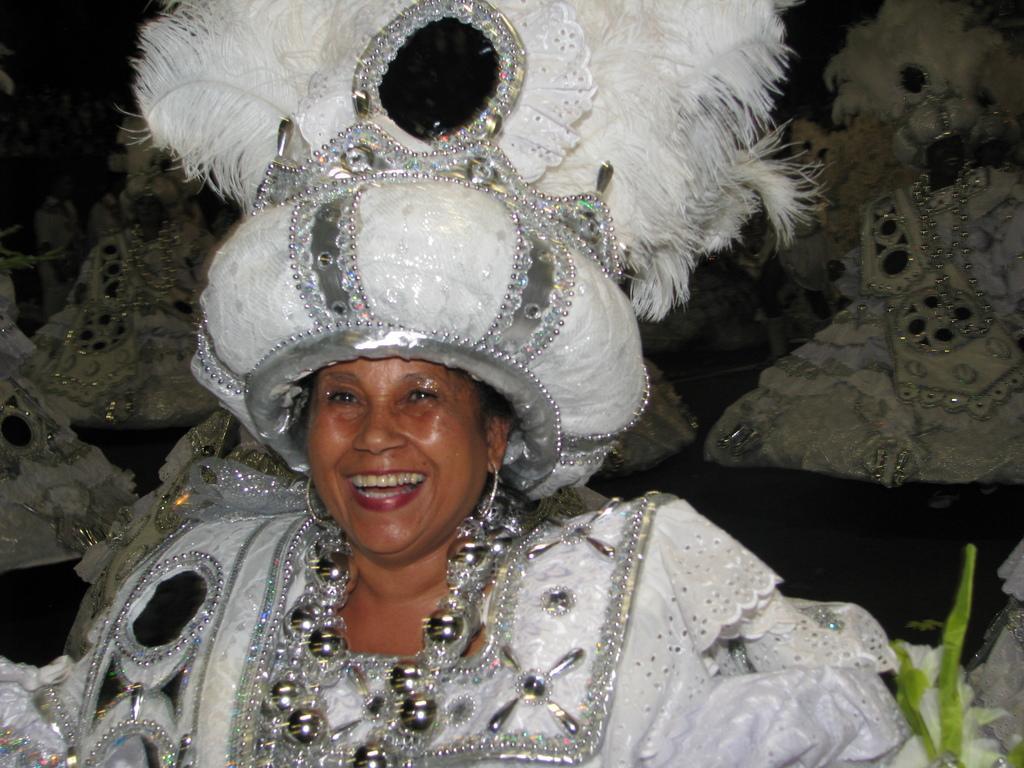In one or two sentences, can you explain what this image depicts? This image consists of a woman wearing a white dress. On the right, there is a small plant. In the background, there are many people. 